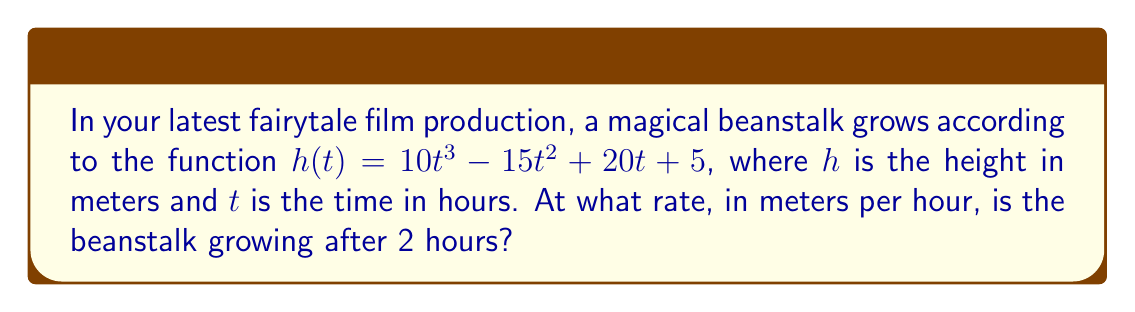Help me with this question. To find the rate of change of the beanstalk's height at t = 2 hours, we need to calculate the derivative of the height function h(t) and evaluate it at t = 2.

Step 1: Find the derivative of h(t)
$$\frac{d}{dt}h(t) = \frac{d}{dt}(10t^3 - 15t^2 + 20t + 5)$$
$$h'(t) = 30t^2 - 30t + 20$$

Step 2: Evaluate h'(t) at t = 2
$$h'(2) = 30(2)^2 - 30(2) + 20$$
$$h'(2) = 30(4) - 60 + 20$$
$$h'(2) = 120 - 60 + 20$$
$$h'(2) = 80$$

The rate of change at t = 2 hours is 80 meters per hour.
Answer: 80 m/h 